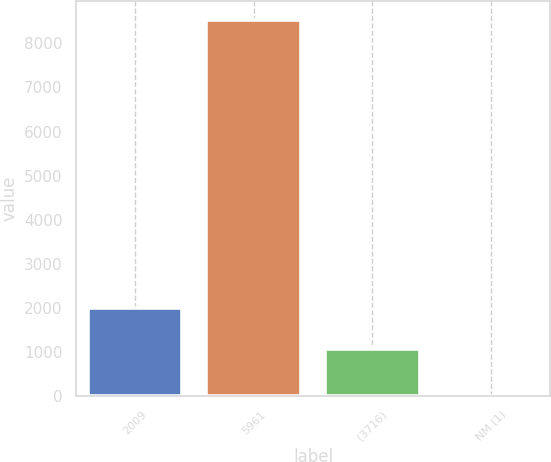<chart> <loc_0><loc_0><loc_500><loc_500><bar_chart><fcel>2009<fcel>5961<fcel>(3716)<fcel>NM (1)<nl><fcel>2007<fcel>8531<fcel>1063<fcel>12.5<nl></chart> 